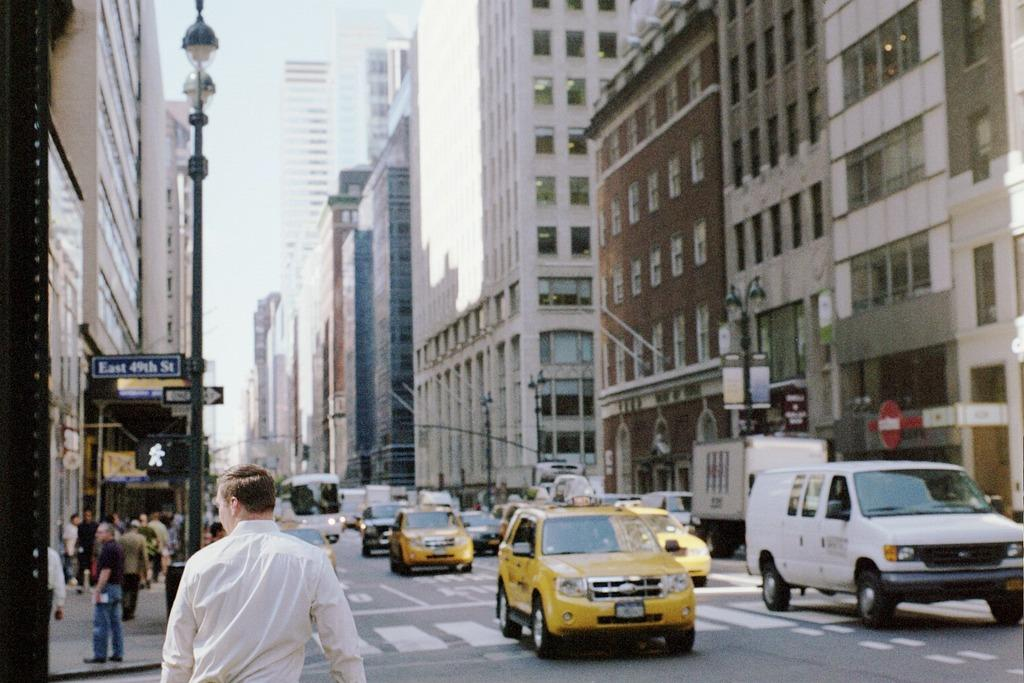<image>
Describe the image concisely. A SUV yellow taxi cab is crossing East 49th St. 